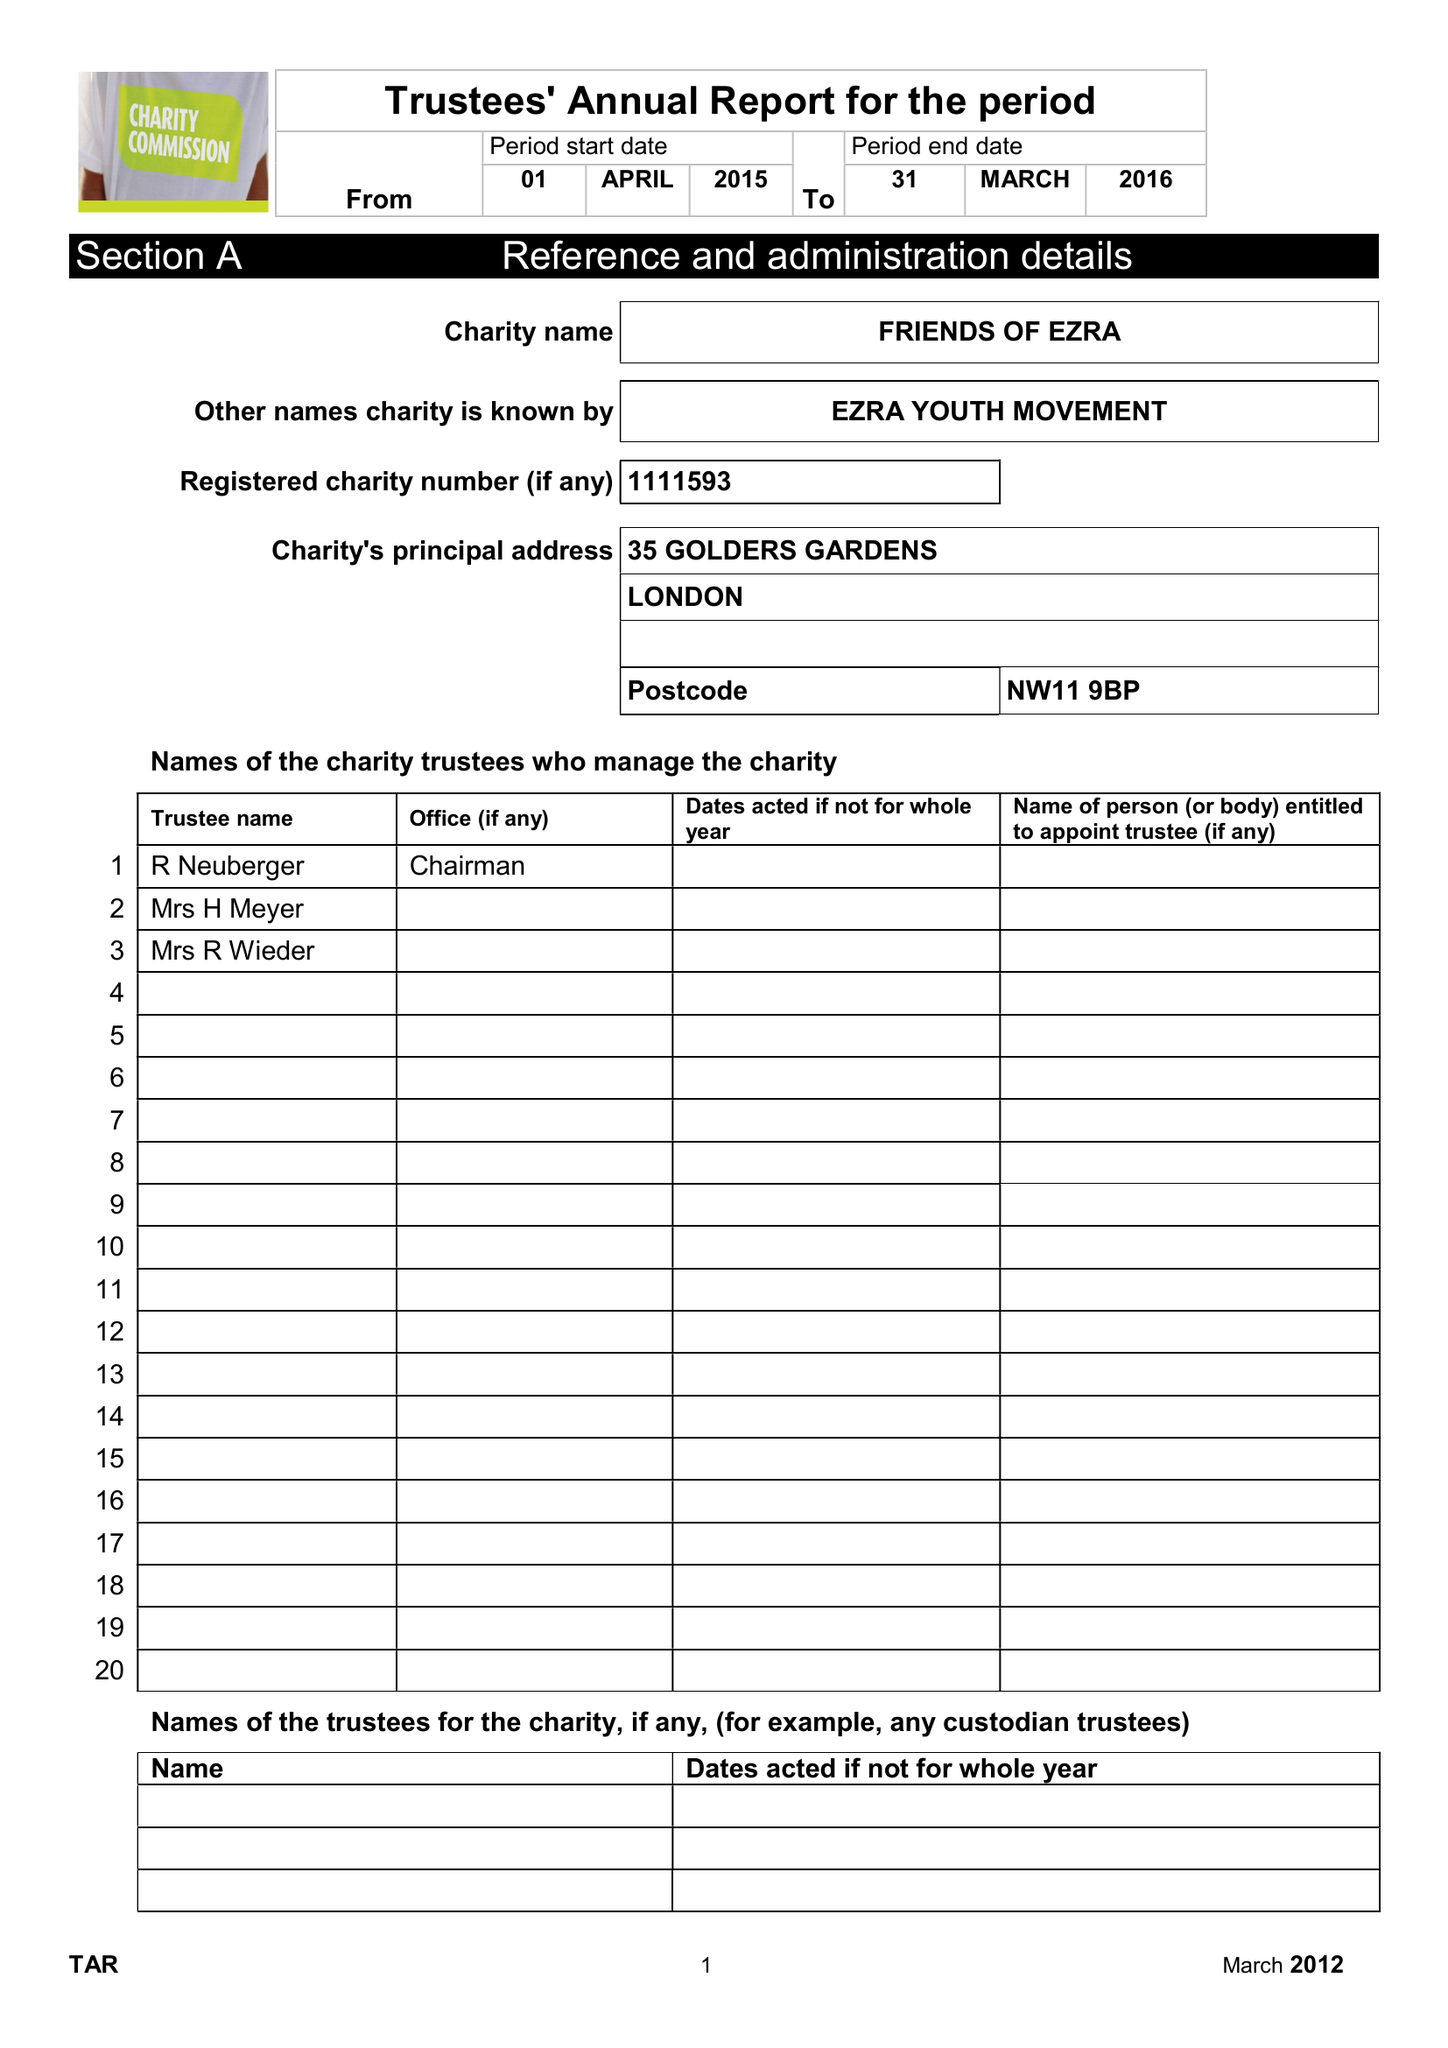What is the value for the charity_number?
Answer the question using a single word or phrase. 1111593 